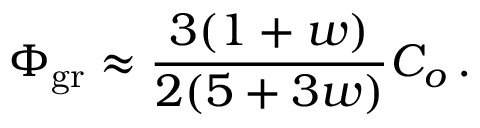Convert formula to latex. <formula><loc_0><loc_0><loc_500><loc_500>\Phi _ { g r } \approx { \frac { 3 ( 1 + w ) } { 2 ( 5 + 3 w ) } } C _ { o } \, .</formula> 